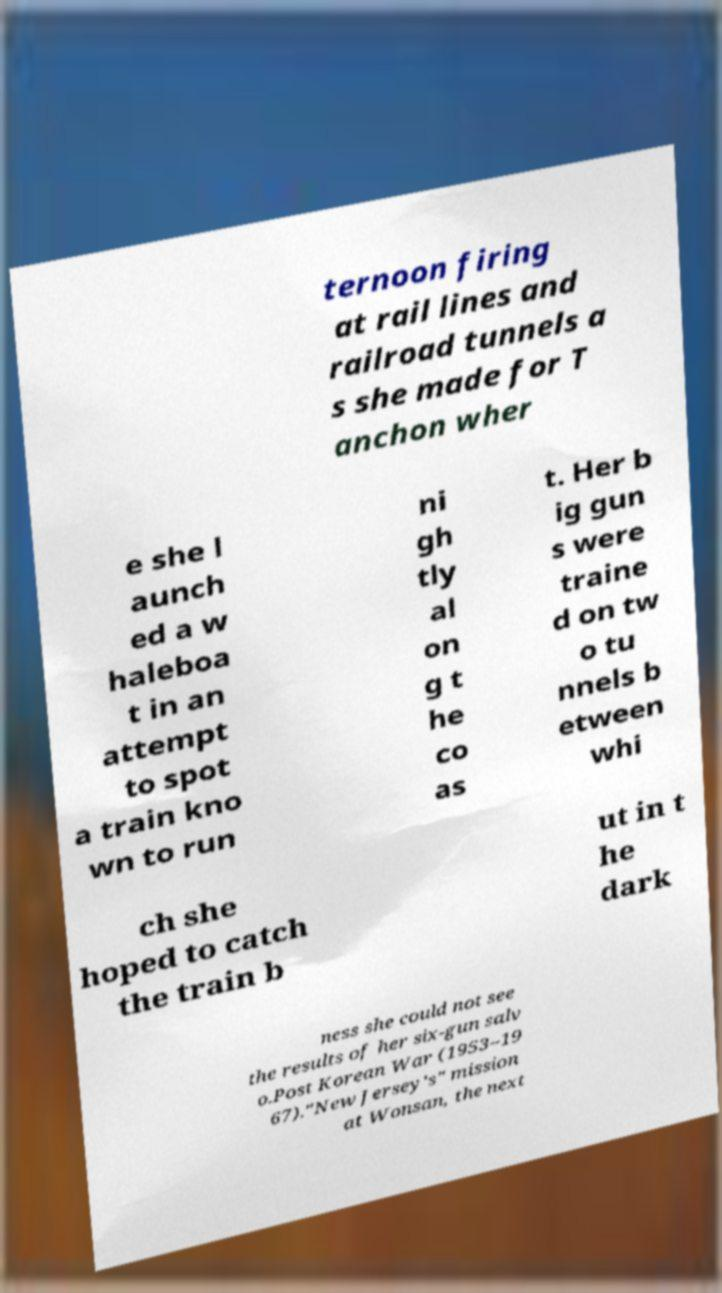Please identify and transcribe the text found in this image. ternoon firing at rail lines and railroad tunnels a s she made for T anchon wher e she l aunch ed a w haleboa t in an attempt to spot a train kno wn to run ni gh tly al on g t he co as t. Her b ig gun s were traine d on tw o tu nnels b etween whi ch she hoped to catch the train b ut in t he dark ness she could not see the results of her six-gun salv o.Post Korean War (1953–19 67)."New Jersey's" mission at Wonsan, the next 